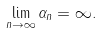<formula> <loc_0><loc_0><loc_500><loc_500>\lim _ { n \rightarrow \infty } \alpha _ { n } = \infty .</formula> 